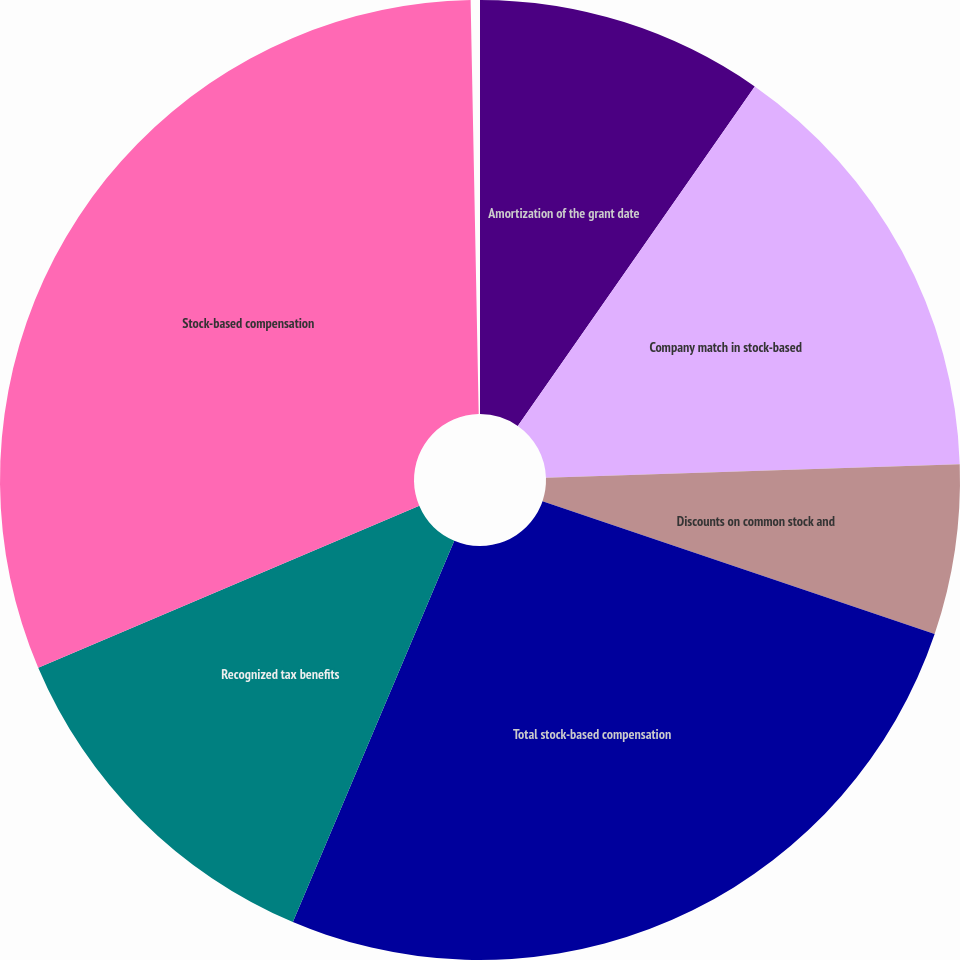Convert chart to OTSL. <chart><loc_0><loc_0><loc_500><loc_500><pie_chart><fcel>Amortization of the grant date<fcel>Company match in stock-based<fcel>Discounts on common stock and<fcel>Total stock-based compensation<fcel>Recognized tax benefits<fcel>Stock-based compensation<nl><fcel>9.73%<fcel>14.82%<fcel>5.74%<fcel>26.26%<fcel>12.27%<fcel>31.18%<nl></chart> 